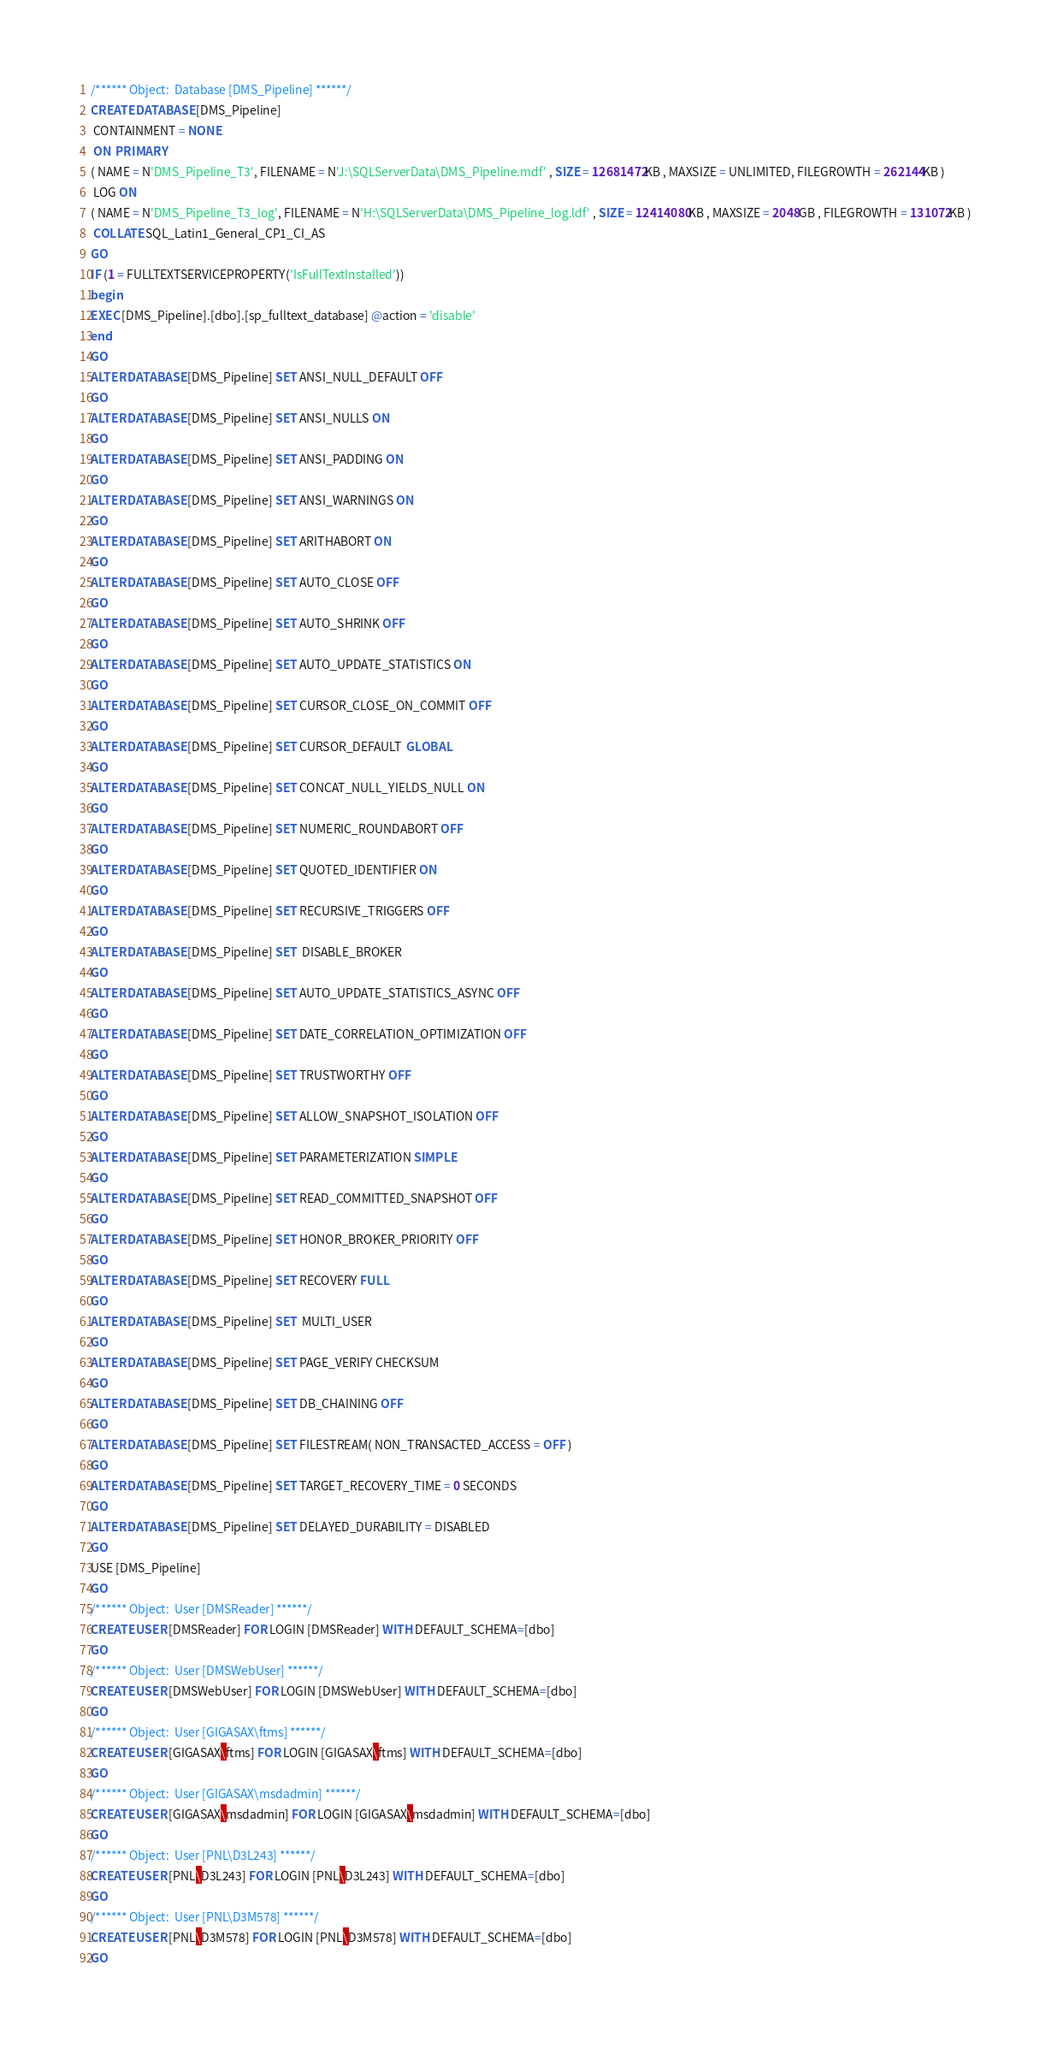Convert code to text. <code><loc_0><loc_0><loc_500><loc_500><_SQL_>/****** Object:  Database [DMS_Pipeline] ******/
CREATE DATABASE [DMS_Pipeline]
 CONTAINMENT = NONE
 ON  PRIMARY 
( NAME = N'DMS_Pipeline_T3', FILENAME = N'J:\SQLServerData\DMS_Pipeline.mdf' , SIZE = 12681472KB , MAXSIZE = UNLIMITED, FILEGROWTH = 262144KB )
 LOG ON 
( NAME = N'DMS_Pipeline_T3_log', FILENAME = N'H:\SQLServerData\DMS_Pipeline_log.ldf' , SIZE = 12414080KB , MAXSIZE = 2048GB , FILEGROWTH = 131072KB )
 COLLATE SQL_Latin1_General_CP1_CI_AS
GO
IF (1 = FULLTEXTSERVICEPROPERTY('IsFullTextInstalled'))
begin
EXEC [DMS_Pipeline].[dbo].[sp_fulltext_database] @action = 'disable'
end
GO
ALTER DATABASE [DMS_Pipeline] SET ANSI_NULL_DEFAULT OFF 
GO
ALTER DATABASE [DMS_Pipeline] SET ANSI_NULLS ON 
GO
ALTER DATABASE [DMS_Pipeline] SET ANSI_PADDING ON 
GO
ALTER DATABASE [DMS_Pipeline] SET ANSI_WARNINGS ON 
GO
ALTER DATABASE [DMS_Pipeline] SET ARITHABORT ON 
GO
ALTER DATABASE [DMS_Pipeline] SET AUTO_CLOSE OFF 
GO
ALTER DATABASE [DMS_Pipeline] SET AUTO_SHRINK OFF 
GO
ALTER DATABASE [DMS_Pipeline] SET AUTO_UPDATE_STATISTICS ON 
GO
ALTER DATABASE [DMS_Pipeline] SET CURSOR_CLOSE_ON_COMMIT OFF 
GO
ALTER DATABASE [DMS_Pipeline] SET CURSOR_DEFAULT  GLOBAL 
GO
ALTER DATABASE [DMS_Pipeline] SET CONCAT_NULL_YIELDS_NULL ON 
GO
ALTER DATABASE [DMS_Pipeline] SET NUMERIC_ROUNDABORT OFF 
GO
ALTER DATABASE [DMS_Pipeline] SET QUOTED_IDENTIFIER ON 
GO
ALTER DATABASE [DMS_Pipeline] SET RECURSIVE_TRIGGERS OFF 
GO
ALTER DATABASE [DMS_Pipeline] SET  DISABLE_BROKER 
GO
ALTER DATABASE [DMS_Pipeline] SET AUTO_UPDATE_STATISTICS_ASYNC OFF 
GO
ALTER DATABASE [DMS_Pipeline] SET DATE_CORRELATION_OPTIMIZATION OFF 
GO
ALTER DATABASE [DMS_Pipeline] SET TRUSTWORTHY OFF 
GO
ALTER DATABASE [DMS_Pipeline] SET ALLOW_SNAPSHOT_ISOLATION OFF 
GO
ALTER DATABASE [DMS_Pipeline] SET PARAMETERIZATION SIMPLE 
GO
ALTER DATABASE [DMS_Pipeline] SET READ_COMMITTED_SNAPSHOT OFF 
GO
ALTER DATABASE [DMS_Pipeline] SET HONOR_BROKER_PRIORITY OFF 
GO
ALTER DATABASE [DMS_Pipeline] SET RECOVERY FULL 
GO
ALTER DATABASE [DMS_Pipeline] SET  MULTI_USER 
GO
ALTER DATABASE [DMS_Pipeline] SET PAGE_VERIFY CHECKSUM  
GO
ALTER DATABASE [DMS_Pipeline] SET DB_CHAINING OFF 
GO
ALTER DATABASE [DMS_Pipeline] SET FILESTREAM( NON_TRANSACTED_ACCESS = OFF ) 
GO
ALTER DATABASE [DMS_Pipeline] SET TARGET_RECOVERY_TIME = 0 SECONDS 
GO
ALTER DATABASE [DMS_Pipeline] SET DELAYED_DURABILITY = DISABLED 
GO
USE [DMS_Pipeline]
GO
/****** Object:  User [DMSReader] ******/
CREATE USER [DMSReader] FOR LOGIN [DMSReader] WITH DEFAULT_SCHEMA=[dbo]
GO
/****** Object:  User [DMSWebUser] ******/
CREATE USER [DMSWebUser] FOR LOGIN [DMSWebUser] WITH DEFAULT_SCHEMA=[dbo]
GO
/****** Object:  User [GIGASAX\ftms] ******/
CREATE USER [GIGASAX\ftms] FOR LOGIN [GIGASAX\ftms] WITH DEFAULT_SCHEMA=[dbo]
GO
/****** Object:  User [GIGASAX\msdadmin] ******/
CREATE USER [GIGASAX\msdadmin] FOR LOGIN [GIGASAX\msdadmin] WITH DEFAULT_SCHEMA=[dbo]
GO
/****** Object:  User [PNL\D3L243] ******/
CREATE USER [PNL\D3L243] FOR LOGIN [PNL\D3L243] WITH DEFAULT_SCHEMA=[dbo]
GO
/****** Object:  User [PNL\D3M578] ******/
CREATE USER [PNL\D3M578] FOR LOGIN [PNL\D3M578] WITH DEFAULT_SCHEMA=[dbo]
GO</code> 